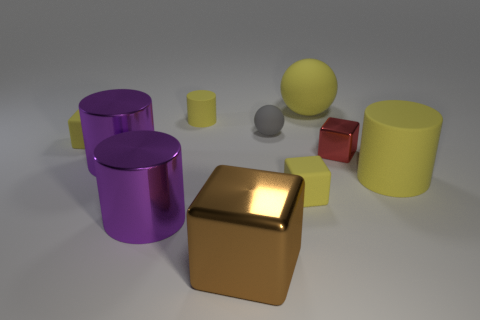Are there fewer large brown shiny objects than purple cylinders?
Give a very brief answer. Yes. How many other things are there of the same color as the big sphere?
Keep it short and to the point. 4. How many large rubber things are there?
Provide a succinct answer. 2. Are there fewer big matte spheres that are on the left side of the big rubber cylinder than small red objects?
Offer a very short reply. No. Do the yellow cylinder on the right side of the tiny ball and the red thing have the same material?
Your answer should be very brief. No. The large yellow object that is in front of the big purple object that is behind the yellow object to the right of the big yellow matte sphere is what shape?
Your answer should be very brief. Cylinder. Is there a red cube that has the same size as the red object?
Provide a succinct answer. No. What is the size of the red object?
Provide a short and direct response. Small. What number of green blocks have the same size as the yellow matte ball?
Make the answer very short. 0. Is the number of gray things that are behind the large yellow sphere less than the number of yellow cylinders in front of the small red thing?
Ensure brevity in your answer.  Yes. 